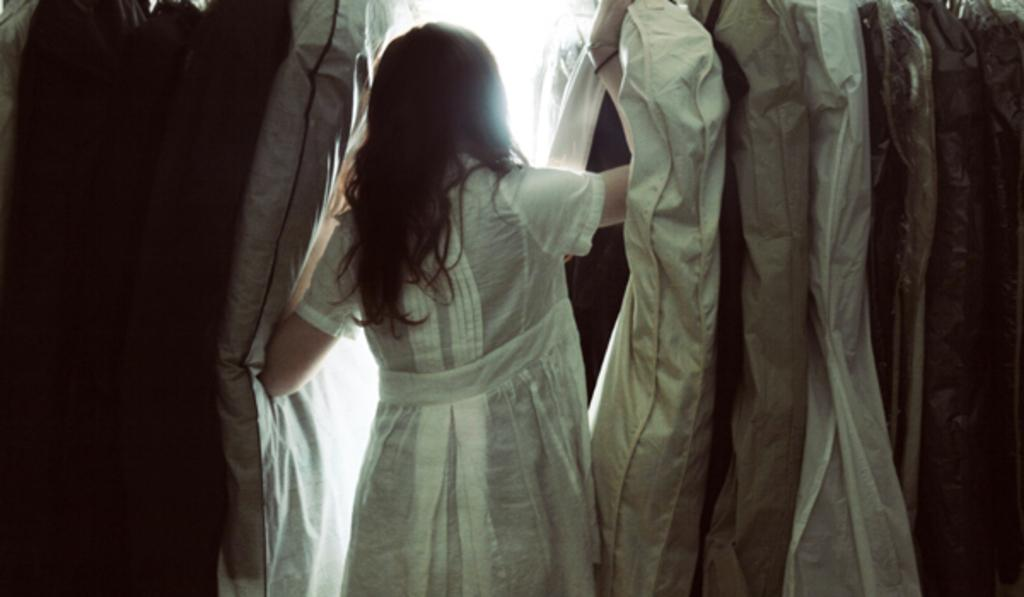Who is present in the image? There is a woman in the image. What is the woman wearing? The woman is wearing a white dress. What else can be seen in the image besides the woman? There are clothes visible in the image. What type of medical advice is the woman providing in the image? There is no indication in the image that the woman is providing medical advice or acting as a doctor. 